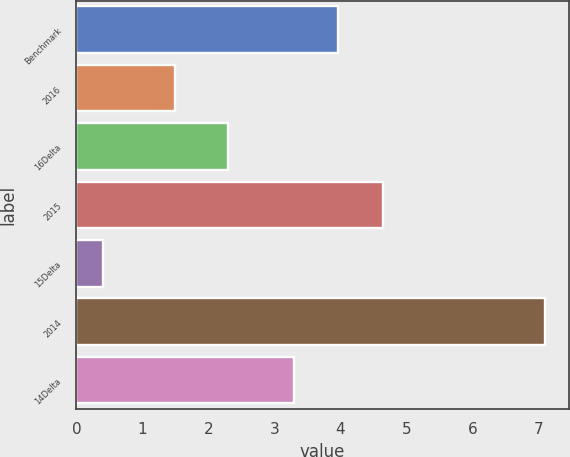<chart> <loc_0><loc_0><loc_500><loc_500><bar_chart><fcel>Benchmark<fcel>2016<fcel>16Delta<fcel>2015<fcel>15Delta<fcel>2014<fcel>14Delta<nl><fcel>3.97<fcel>1.5<fcel>2.3<fcel>4.64<fcel>0.4<fcel>7.1<fcel>3.3<nl></chart> 